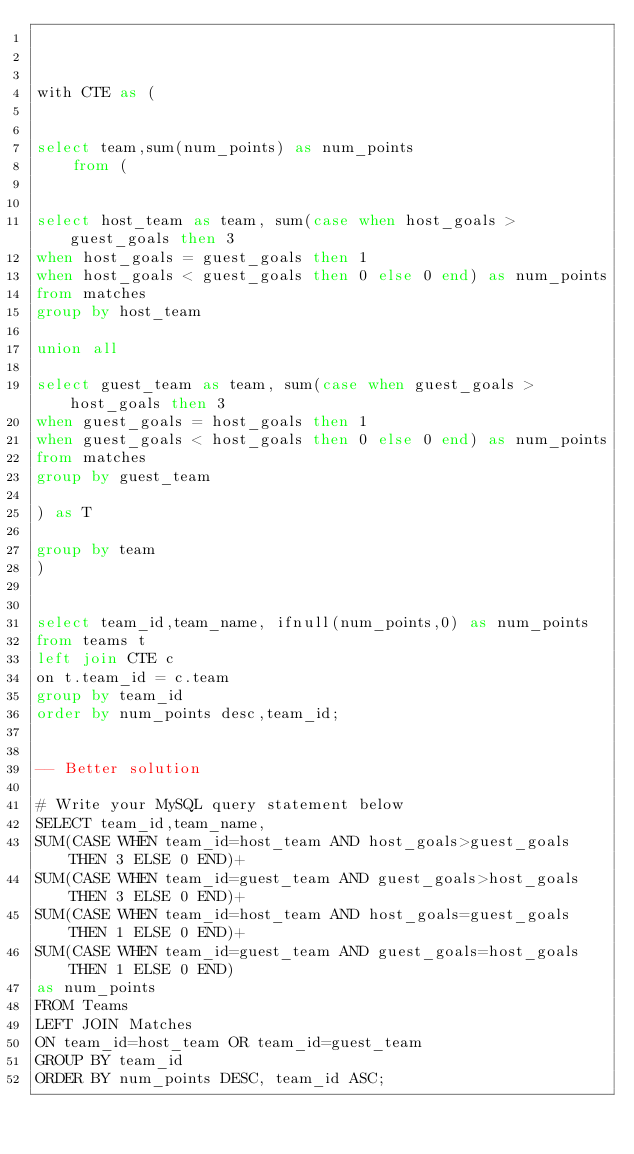Convert code to text. <code><loc_0><loc_0><loc_500><loc_500><_SQL_>


with CTE as (
    

select team,sum(num_points) as num_points    
    from (
    
    
select host_team as team, sum(case when host_goals > guest_goals then 3
when host_goals = guest_goals then 1
when host_goals < guest_goals then 0 else 0 end) as num_points
from matches
group by host_team
    
union all
    
select guest_team as team, sum(case when guest_goals > host_goals then 3
when guest_goals = host_goals then 1
when guest_goals < host_goals then 0 else 0 end) as num_points
from matches
group by guest_team
    
) as T

group by team
)    


select team_id,team_name, ifnull(num_points,0) as num_points
from teams t
left join CTE c
on t.team_id = c.team
group by team_id
order by num_points desc,team_id;


-- Better solution

# Write your MySQL query statement below
SELECT team_id,team_name,
SUM(CASE WHEN team_id=host_team AND host_goals>guest_goals THEN 3 ELSE 0 END)+
SUM(CASE WHEN team_id=guest_team AND guest_goals>host_goals THEN 3 ELSE 0 END)+
SUM(CASE WHEN team_id=host_team AND host_goals=guest_goals THEN 1 ELSE 0 END)+
SUM(CASE WHEN team_id=guest_team AND guest_goals=host_goals THEN 1 ELSE 0 END)
as num_points
FROM Teams
LEFT JOIN Matches
ON team_id=host_team OR team_id=guest_team
GROUP BY team_id
ORDER BY num_points DESC, team_id ASC;



</code> 